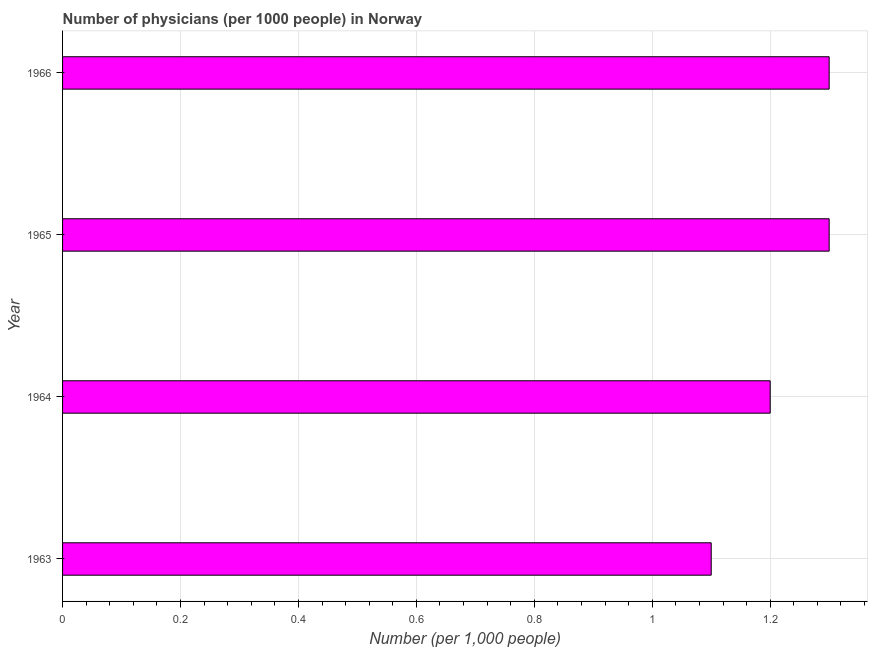Does the graph contain any zero values?
Your answer should be compact. No. Does the graph contain grids?
Your answer should be very brief. Yes. What is the title of the graph?
Your answer should be very brief. Number of physicians (per 1000 people) in Norway. What is the label or title of the X-axis?
Ensure brevity in your answer.  Number (per 1,0 people). What is the label or title of the Y-axis?
Your answer should be compact. Year. Across all years, what is the maximum number of physicians?
Your answer should be compact. 1.3. In which year was the number of physicians maximum?
Provide a short and direct response. 1965. In which year was the number of physicians minimum?
Provide a short and direct response. 1963. What is the sum of the number of physicians?
Your response must be concise. 4.9. What is the difference between the number of physicians in 1963 and 1966?
Ensure brevity in your answer.  -0.2. What is the average number of physicians per year?
Your answer should be very brief. 1.23. What is the median number of physicians?
Your response must be concise. 1.25. Do a majority of the years between 1964 and 1965 (inclusive) have number of physicians greater than 0.32 ?
Your answer should be very brief. Yes. What is the ratio of the number of physicians in 1963 to that in 1966?
Give a very brief answer. 0.85. Is the number of physicians in 1965 less than that in 1966?
Provide a succinct answer. No. Is the difference between the number of physicians in 1963 and 1966 greater than the difference between any two years?
Your response must be concise. Yes. In how many years, is the number of physicians greater than the average number of physicians taken over all years?
Your answer should be compact. 2. How many bars are there?
Provide a succinct answer. 4. How many years are there in the graph?
Provide a succinct answer. 4. Are the values on the major ticks of X-axis written in scientific E-notation?
Provide a succinct answer. No. What is the Number (per 1,000 people) in 1963?
Your answer should be very brief. 1.1. What is the difference between the Number (per 1,000 people) in 1963 and 1966?
Make the answer very short. -0.2. What is the ratio of the Number (per 1,000 people) in 1963 to that in 1964?
Offer a terse response. 0.92. What is the ratio of the Number (per 1,000 people) in 1963 to that in 1965?
Give a very brief answer. 0.85. What is the ratio of the Number (per 1,000 people) in 1963 to that in 1966?
Offer a very short reply. 0.85. What is the ratio of the Number (per 1,000 people) in 1964 to that in 1965?
Provide a succinct answer. 0.92. What is the ratio of the Number (per 1,000 people) in 1964 to that in 1966?
Provide a succinct answer. 0.92. 